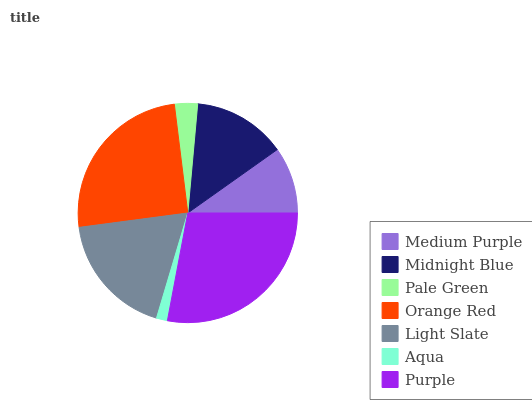Is Aqua the minimum?
Answer yes or no. Yes. Is Purple the maximum?
Answer yes or no. Yes. Is Midnight Blue the minimum?
Answer yes or no. No. Is Midnight Blue the maximum?
Answer yes or no. No. Is Midnight Blue greater than Medium Purple?
Answer yes or no. Yes. Is Medium Purple less than Midnight Blue?
Answer yes or no. Yes. Is Medium Purple greater than Midnight Blue?
Answer yes or no. No. Is Midnight Blue less than Medium Purple?
Answer yes or no. No. Is Midnight Blue the high median?
Answer yes or no. Yes. Is Midnight Blue the low median?
Answer yes or no. Yes. Is Pale Green the high median?
Answer yes or no. No. Is Purple the low median?
Answer yes or no. No. 